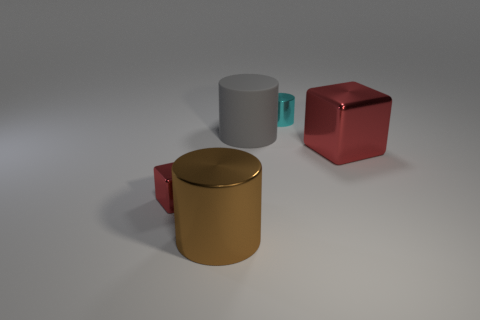There is a brown metallic object that is to the left of the small metal object on the right side of the gray thing; what is its size?
Make the answer very short. Large. There is another big metallic thing that is the same shape as the cyan metal object; what is its color?
Give a very brief answer. Brown. What is the size of the gray rubber cylinder?
Your answer should be very brief. Large. How many balls are small green things or metal objects?
Make the answer very short. 0. There is a rubber thing that is the same shape as the tiny cyan metal thing; what size is it?
Offer a terse response. Large. What number of red shiny objects are there?
Your answer should be very brief. 2. There is a tiny cyan shiny object; is it the same shape as the tiny metal object on the left side of the cyan cylinder?
Make the answer very short. No. What size is the metallic cylinder in front of the small red cube?
Give a very brief answer. Large. What material is the large brown cylinder?
Offer a very short reply. Metal. Does the tiny metal thing behind the large rubber object have the same shape as the large gray thing?
Offer a very short reply. Yes. 